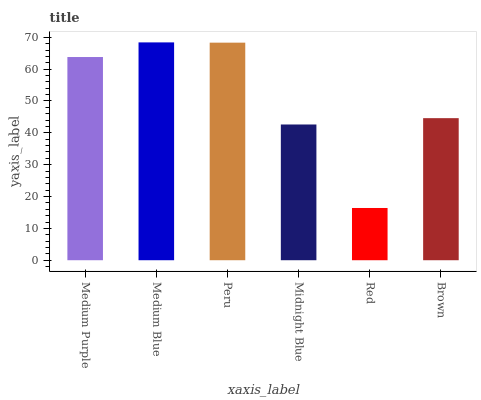Is Peru the minimum?
Answer yes or no. No. Is Peru the maximum?
Answer yes or no. No. Is Medium Blue greater than Peru?
Answer yes or no. Yes. Is Peru less than Medium Blue?
Answer yes or no. Yes. Is Peru greater than Medium Blue?
Answer yes or no. No. Is Medium Blue less than Peru?
Answer yes or no. No. Is Medium Purple the high median?
Answer yes or no. Yes. Is Brown the low median?
Answer yes or no. Yes. Is Red the high median?
Answer yes or no. No. Is Medium Purple the low median?
Answer yes or no. No. 